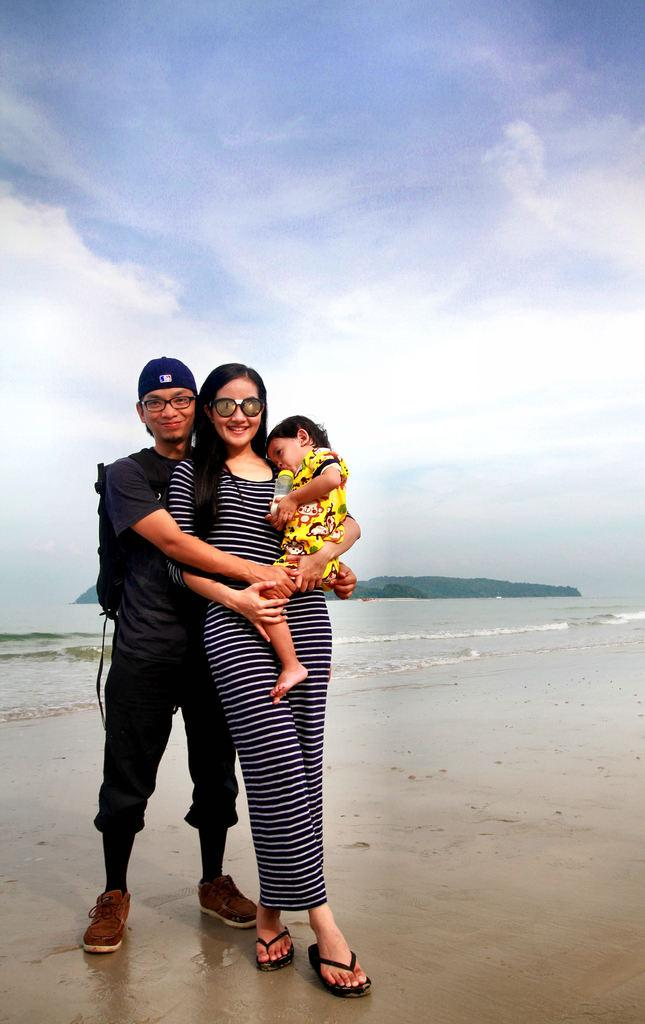How many people are standing in the image? There are 2 people standing in the image. What is the woman doing in the image? The woman is carrying a child in the image. What can be seen in the background of the image? There is water visible in the image, and trees are at the back of the image. Are there any mountains visible in the image? No, there are no mountains visible in the image. 